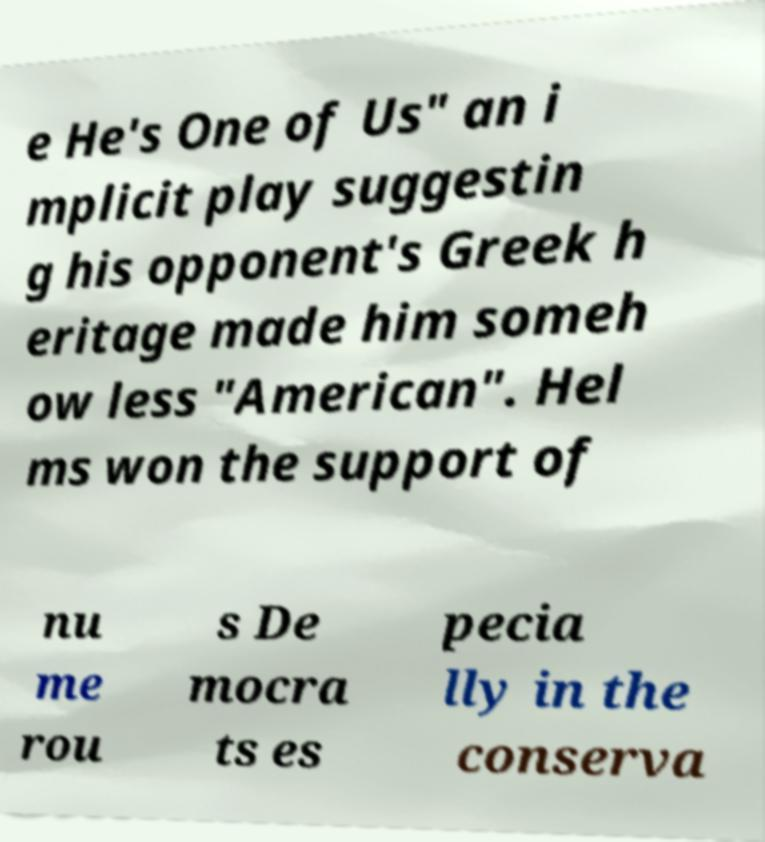For documentation purposes, I need the text within this image transcribed. Could you provide that? e He's One of Us" an i mplicit play suggestin g his opponent's Greek h eritage made him someh ow less "American". Hel ms won the support of nu me rou s De mocra ts es pecia lly in the conserva 